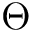<formula> <loc_0><loc_0><loc_500><loc_500>\Theta</formula> 